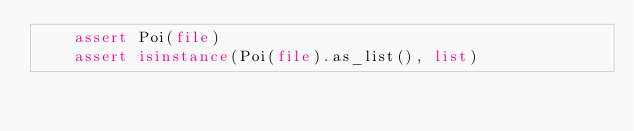<code> <loc_0><loc_0><loc_500><loc_500><_Python_>    assert Poi(file)
    assert isinstance(Poi(file).as_list(), list)
</code> 